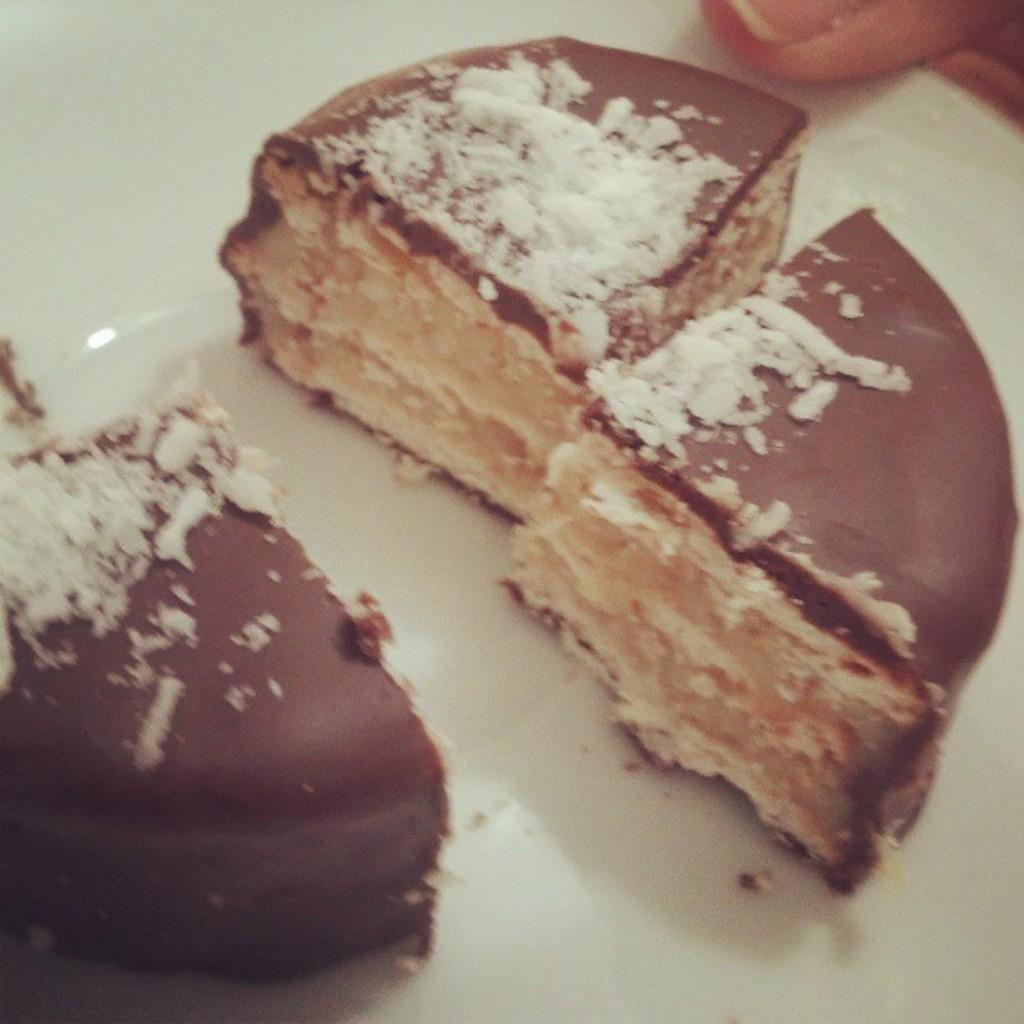What type of food is present on the plate in the image? There are pieces of cake in a plate in the image. Can you describe any other elements in the image? The finger of a person is visible at the top of the image. What type of brass instrument is being played in the image? There is no brass instrument present in the image; it only features pieces of cake and a finger. 